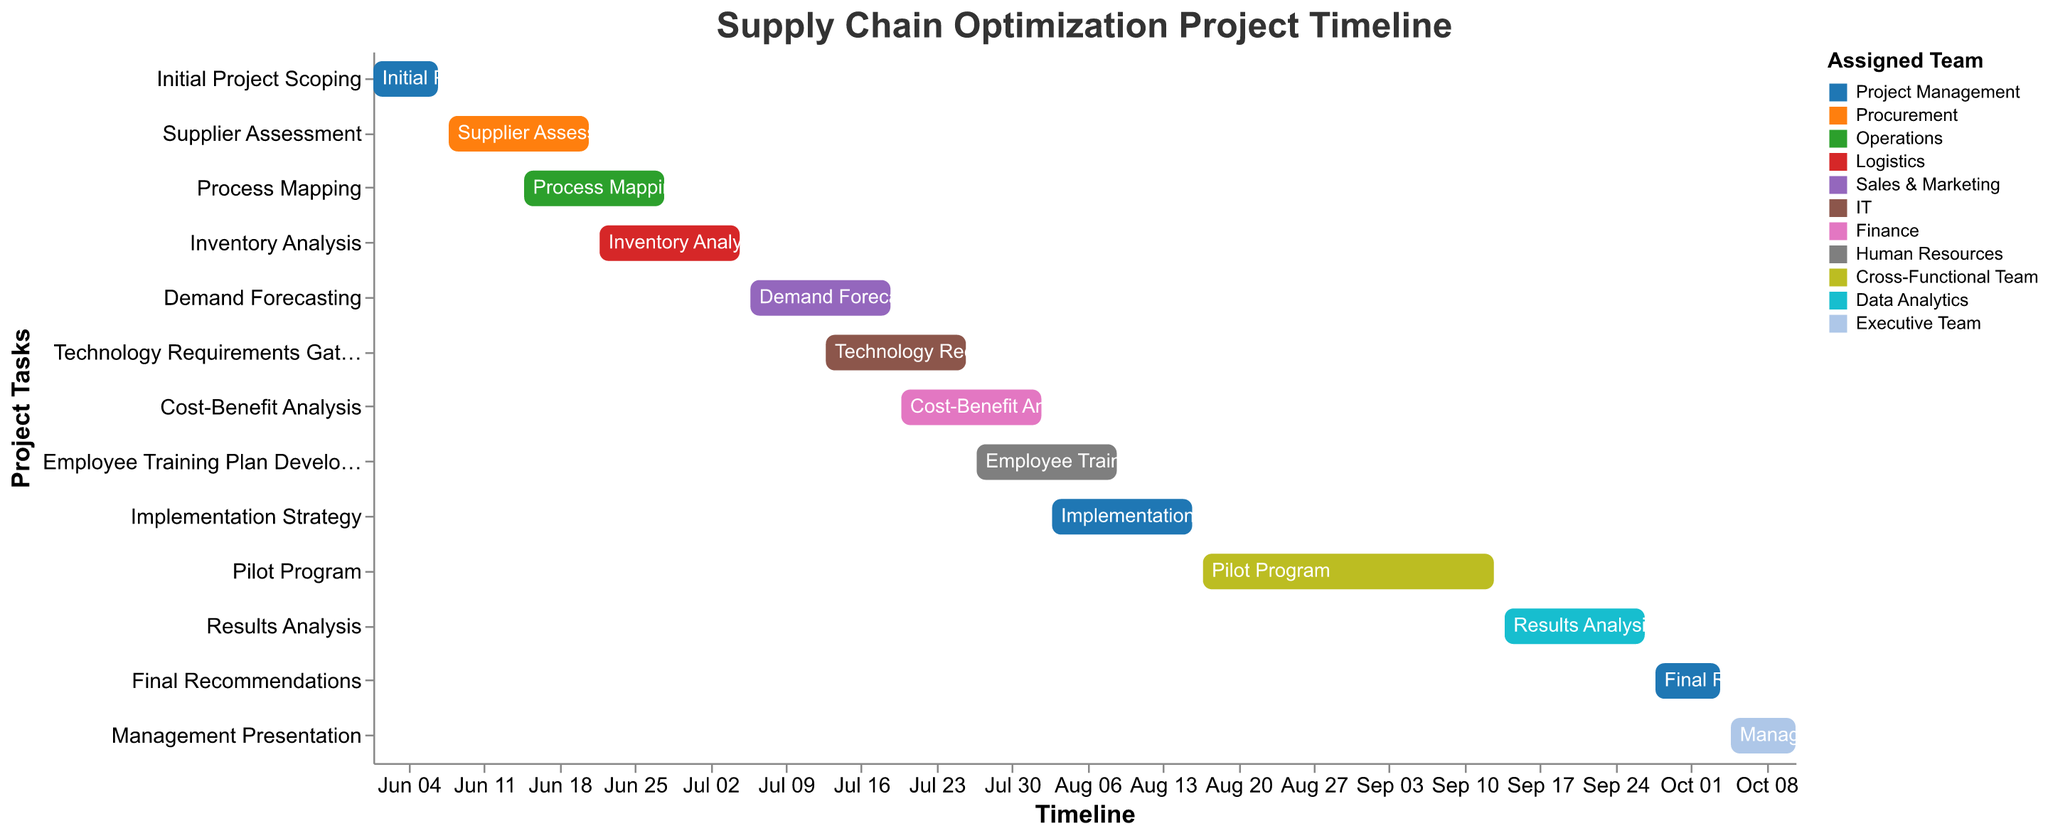What's the title of the Gantt Chart? The title is located at the top of the chart. It is "Supply Chain Optimization Project Timeline".
Answer: Supply Chain Optimization Project Timeline Which team is assigned to the "Demand Forecasting" task? The task of "Demand Forecasting" is indicated with a specific color in the chart, and it is assigned to "Sales & Marketing".
Answer: Sales & Marketing How long does the "Pilot Program" run? The duration for each task is indicated in the data. The "Pilot Program" runs from 2023-08-17 to 2023-09-13, which is 28 days.
Answer: 28 days What is the shortest task in terms of duration? To find the task with the shortest duration, look for the task bars that span the least number of days on the timeline. "Initial Project Scoping", "Final Recommendations", and "Management Presentation" are all 7 days long.
Answer: Initial Project Scoping, Final Recommendations, Management Presentation Which task overlaps with "Technology Requirements Gathering"? By checking the start and end dates of each task, it's evident that "Technology Requirements Gathering" (2023-07-13 to 2023-07-26) overlaps with "Demand Forecasting" (2023-07-06 to 2023-07-19), "Cost-Benefit Analysis" (2023-07-20 to 2023-08-02), and "Employee Training Plan Development" (2023-07-27 to 2023-08-09).
Answer: Demand Forecasting, Cost-Benefit Analysis, Employee Training Plan Development Which team has the most number of tasks assigned? By counting the number of tasks per team from the color legend, "Project Management" has three tasks: "Initial Project Scoping", "Implementation Strategy", and "Final Recommendations".
Answer: Project Management What is the difference in days between the start of "Supplier Assessment" and the end of "Cost-Benefit Analysis"? "Supplier Assessment" starts on 2023-06-08, "Cost-Benefit Analysis" ends on 2023-08-02. The difference from 2023-06-08 to 2023-08-02 is 55 days.
Answer: 55 days Which task comes immediately before "Employee Training Plan Development"? By checking the sequence of start and end dates, "Cost-Benefit Analysis" (2023-07-20 to 2023-08-02) directly precedes "Employee Training Plan Development" (2023-07-27 to 2023-08-09).
Answer: Cost-Benefit Analysis How many teams are involved in the entire project? By counting the distinct teams listed in the legend or the data, there are eleven teams involved: "Project Management", "Procurement", "Operations", "Logistics", "Sales & Marketing", "IT", "Finance", "Human Resources", "Cross-Functional Team", "Data Analytics", and "Executive Team".
Answer: Eleven teams Is there any task that starts and ends within the same month? By checking the dates, "Initial Project Scoping" (2023-06-01 to 2023-06-07), "Supplier Assessment" (2023-06-08 to 2023-06-21), "Process Mapping" (2023-06-15 to 2023-06-28), "Inventory Analysis" (2023-06-22 to 2023-07-05), "Demand Forecasting" (2023-07-06 to 2023-07-19), "Technology Requirements Gathering" (2023-07-13 to 2023-07-26), and "Final Recommendations" (2023-09-28 to 2023-10-04) all start and end within the same month.
Answer: Yes 